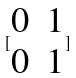<formula> <loc_0><loc_0><loc_500><loc_500>[ \begin{matrix} 0 & 1 \\ 0 & 1 \end{matrix} ]</formula> 